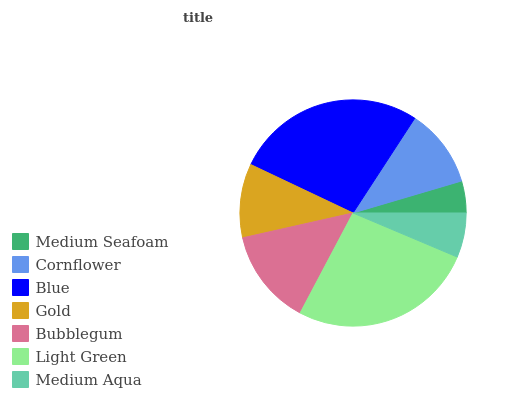Is Medium Seafoam the minimum?
Answer yes or no. Yes. Is Blue the maximum?
Answer yes or no. Yes. Is Cornflower the minimum?
Answer yes or no. No. Is Cornflower the maximum?
Answer yes or no. No. Is Cornflower greater than Medium Seafoam?
Answer yes or no. Yes. Is Medium Seafoam less than Cornflower?
Answer yes or no. Yes. Is Medium Seafoam greater than Cornflower?
Answer yes or no. No. Is Cornflower less than Medium Seafoam?
Answer yes or no. No. Is Cornflower the high median?
Answer yes or no. Yes. Is Cornflower the low median?
Answer yes or no. Yes. Is Blue the high median?
Answer yes or no. No. Is Bubblegum the low median?
Answer yes or no. No. 